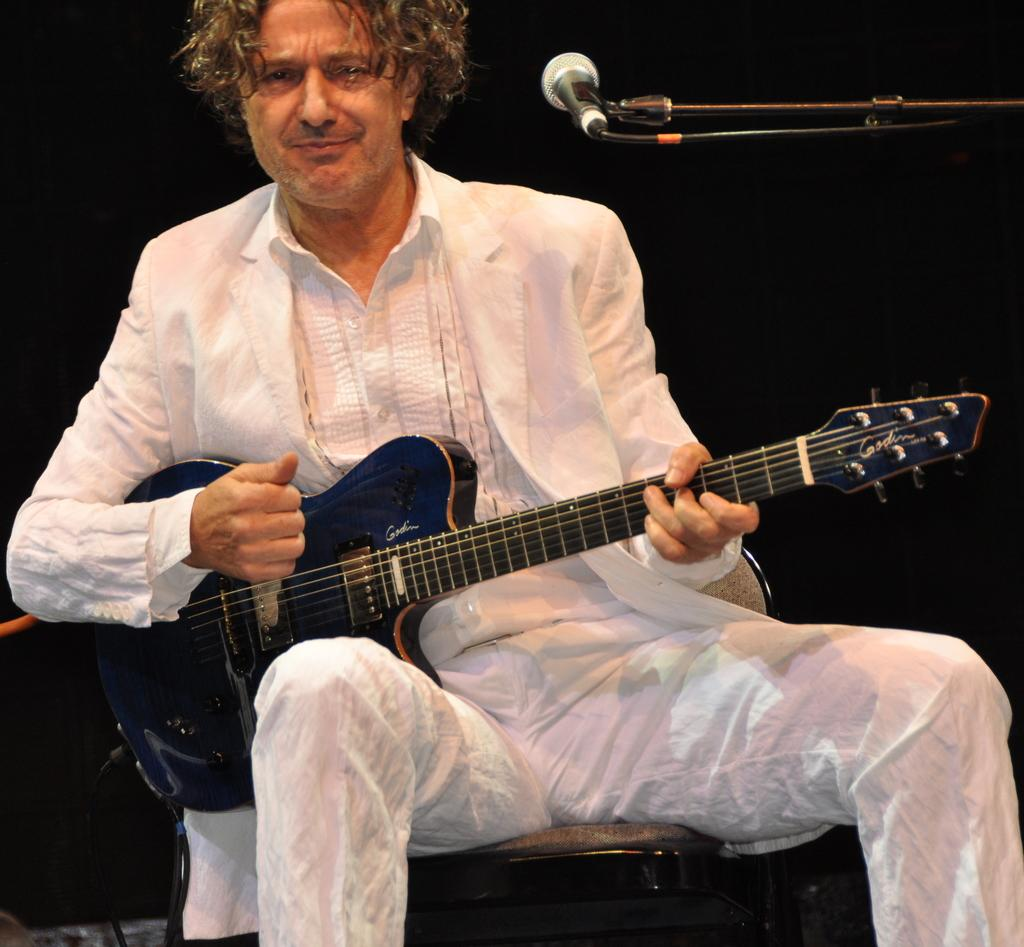What is the person in the image doing? The person is sitting and holding a guitar. What activity is the person engaged in? The person is singing. What object is present in front of the person? There is a microphone present in front of the person. How many spiders are crawling on the guitar in the image? There are no spiders present in the image; the person is holding a guitar while singing. 